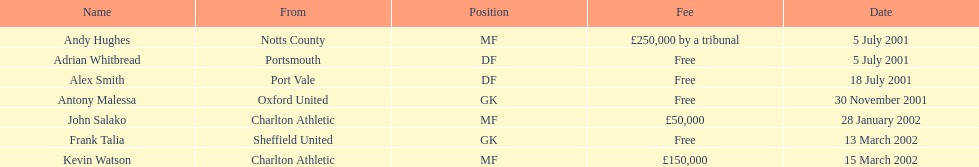Andy huges and adrian whitbread both tranfered on which date? 5 July 2001. 